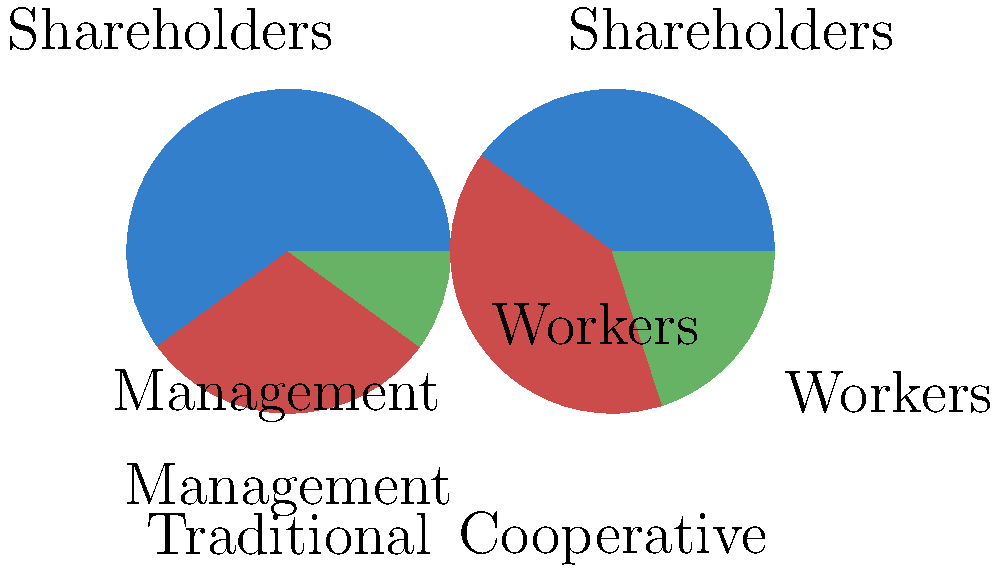Based on the pie charts comparing profit distribution in traditional and cooperative business models, what is the percentage difference in worker profit share between the two models? To find the percentage difference in worker profit share between the two models, we need to follow these steps:

1. Identify the worker profit share in each model:
   - Traditional model: 10%
   - Cooperative model: 20%

2. Calculate the difference in worker profit share:
   20% - 10% = 10%

3. The question asks for the percentage difference, which is already expressed in percentage points.

Therefore, the percentage difference in worker profit share between the cooperative and traditional business models is 10 percentage points.
Answer: 10 percentage points 